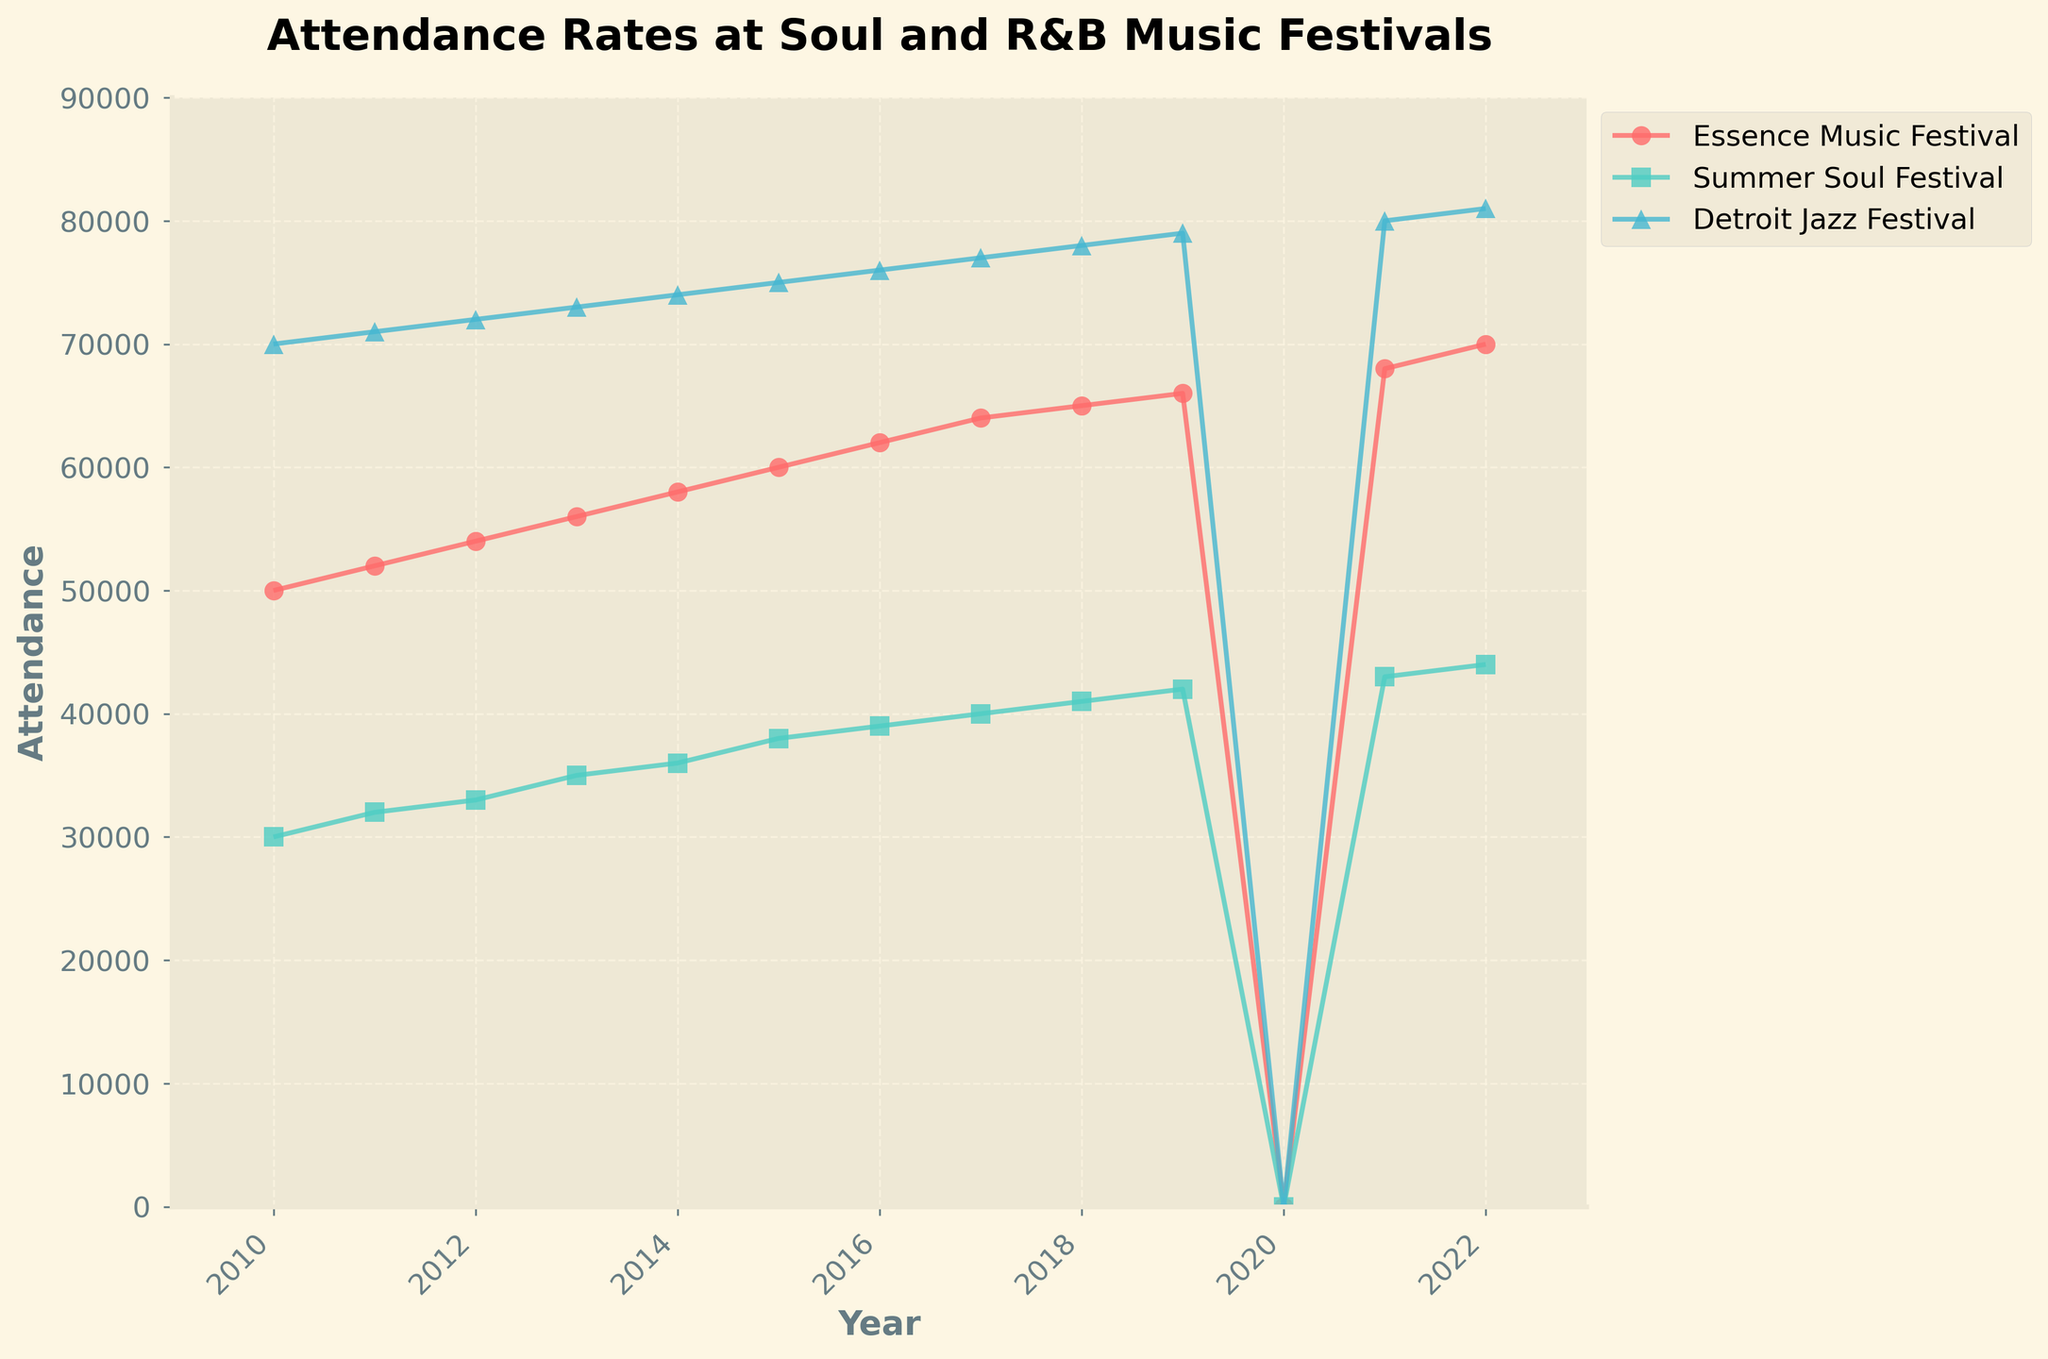what's the title of the plot? The title of the plot is displayed at the top of the figure, usually in a larger and bold font to make it stand out.
Answer: Attendance Rates at Soul and R&B Music Festivals which festival had the highest attendance in 2022? Look for the data points at the year 2022 and compare their heights (attendance values). The highest point will indicate the festival with the highest attendance.
Answer: Detroit Jazz Festival what happened to the attendance of all festivals in 2020? Check the data points around the year 2020 for all festivals. Observe that all values seem to drop to zero. This can be seen as there are no points above the baseline for that year.
Answer: Zero attendance how many festivals are shown in the plot? Identify the number of unique lines or series in the plot, each with its own color and marker. Count the distinct legends listed in the plot's legend section.
Answer: Three what's the range of years shown on the x-axis? Look at the values marked on the x-axis. The first and last years indicate the range.
Answer: 2010 to 2022 which festival had a decreasing trend followed by an increasing trend from 2018 to 2021? Examine the plot lines' patterns between these years. Look for a line that goes down first and then rebounds upwards.
Answer: Essence Music Festival by how much did the attendance of the Summer Soul Festival increase from 2010 to 2015? Note the attendance for the Summer Soul Festival in 2010 and 2015. Subtract the value in 2010 from the value in 2015 to find the difference.
Answer: 8000 between the Essence Music Festival and Detroit Jazz Festival, which one had more attendees in 2011? Locate the 2011 data points for both festivals and compare their attendance values.
Answer: Detroit Jazz Festival what is the attendance trend for the Detroit Jazz Festival from 2010 to 2022? Observe the progression of data points for the Detroit Jazz Festival from 2010 to 2022. Identify whether the points generally increase, decrease, or stay the same.
Answer: Increasing what's the average attendance of the Essence Music Festival from 2010 to 2019? Sum the attendance values for the Essence Music Festival from 2010 to 2019 and divide by the number of these years, which is ten. (50000 + 52000 + 54000 + 56000 + 58000 + 60000 + 62000 + 64000 + 65000 + 66000) / 10 = 58700
Answer: 58700 